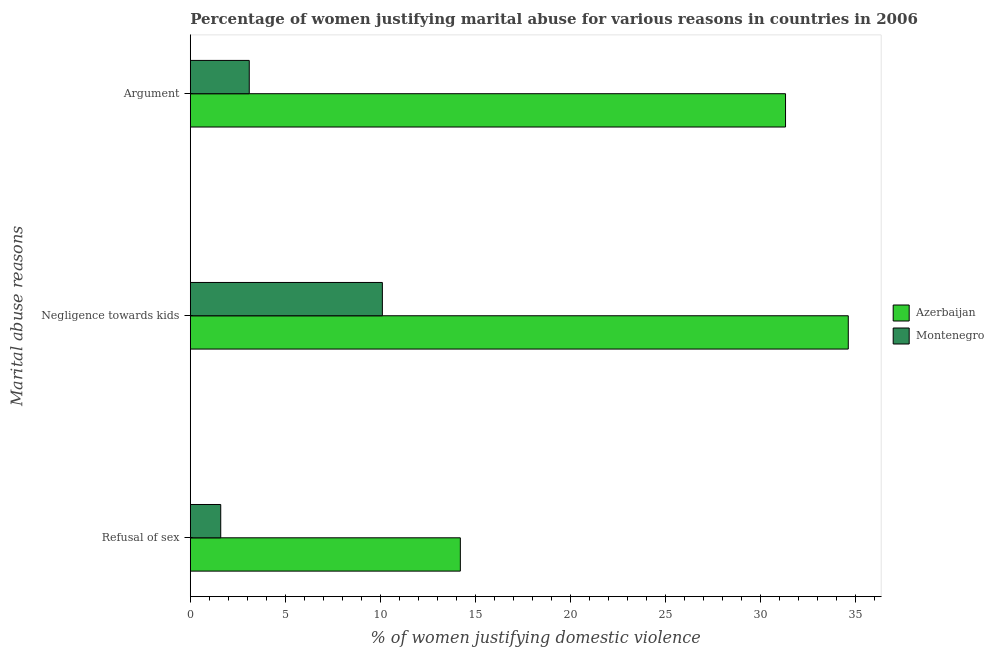Are the number of bars on each tick of the Y-axis equal?
Your answer should be very brief. Yes. How many bars are there on the 1st tick from the top?
Keep it short and to the point. 2. What is the label of the 3rd group of bars from the top?
Make the answer very short. Refusal of sex. What is the percentage of women justifying domestic violence due to arguments in Azerbaijan?
Ensure brevity in your answer.  31.3. Across all countries, what is the maximum percentage of women justifying domestic violence due to negligence towards kids?
Your response must be concise. 34.6. In which country was the percentage of women justifying domestic violence due to arguments maximum?
Make the answer very short. Azerbaijan. In which country was the percentage of women justifying domestic violence due to arguments minimum?
Provide a succinct answer. Montenegro. What is the total percentage of women justifying domestic violence due to refusal of sex in the graph?
Offer a very short reply. 15.8. What is the difference between the percentage of women justifying domestic violence due to negligence towards kids in Azerbaijan and the percentage of women justifying domestic violence due to refusal of sex in Montenegro?
Your response must be concise. 33. What is the average percentage of women justifying domestic violence due to negligence towards kids per country?
Keep it short and to the point. 22.35. What is the difference between the percentage of women justifying domestic violence due to arguments and percentage of women justifying domestic violence due to negligence towards kids in Azerbaijan?
Your answer should be compact. -3.3. What is the ratio of the percentage of women justifying domestic violence due to negligence towards kids in Azerbaijan to that in Montenegro?
Your answer should be very brief. 3.43. Is the percentage of women justifying domestic violence due to arguments in Montenegro less than that in Azerbaijan?
Ensure brevity in your answer.  Yes. Is the difference between the percentage of women justifying domestic violence due to refusal of sex in Azerbaijan and Montenegro greater than the difference between the percentage of women justifying domestic violence due to arguments in Azerbaijan and Montenegro?
Make the answer very short. No. What is the difference between the highest and the lowest percentage of women justifying domestic violence due to refusal of sex?
Your answer should be compact. 12.6. What does the 2nd bar from the top in Negligence towards kids represents?
Provide a short and direct response. Azerbaijan. What does the 1st bar from the bottom in Refusal of sex represents?
Your answer should be compact. Azerbaijan. How many bars are there?
Make the answer very short. 6. Are all the bars in the graph horizontal?
Make the answer very short. Yes. What is the difference between two consecutive major ticks on the X-axis?
Your answer should be compact. 5. Are the values on the major ticks of X-axis written in scientific E-notation?
Offer a very short reply. No. Does the graph contain any zero values?
Your answer should be compact. No. Does the graph contain grids?
Make the answer very short. No. Where does the legend appear in the graph?
Offer a very short reply. Center right. How many legend labels are there?
Your answer should be very brief. 2. How are the legend labels stacked?
Your response must be concise. Vertical. What is the title of the graph?
Offer a terse response. Percentage of women justifying marital abuse for various reasons in countries in 2006. Does "Peru" appear as one of the legend labels in the graph?
Offer a terse response. No. What is the label or title of the X-axis?
Give a very brief answer. % of women justifying domestic violence. What is the label or title of the Y-axis?
Your answer should be compact. Marital abuse reasons. What is the % of women justifying domestic violence of Azerbaijan in Refusal of sex?
Ensure brevity in your answer.  14.2. What is the % of women justifying domestic violence in Azerbaijan in Negligence towards kids?
Make the answer very short. 34.6. What is the % of women justifying domestic violence of Azerbaijan in Argument?
Ensure brevity in your answer.  31.3. Across all Marital abuse reasons, what is the maximum % of women justifying domestic violence of Azerbaijan?
Offer a very short reply. 34.6. Across all Marital abuse reasons, what is the minimum % of women justifying domestic violence in Azerbaijan?
Your response must be concise. 14.2. What is the total % of women justifying domestic violence of Azerbaijan in the graph?
Give a very brief answer. 80.1. What is the difference between the % of women justifying domestic violence in Azerbaijan in Refusal of sex and that in Negligence towards kids?
Keep it short and to the point. -20.4. What is the difference between the % of women justifying domestic violence of Montenegro in Refusal of sex and that in Negligence towards kids?
Provide a short and direct response. -8.5. What is the difference between the % of women justifying domestic violence in Azerbaijan in Refusal of sex and that in Argument?
Provide a succinct answer. -17.1. What is the difference between the % of women justifying domestic violence in Azerbaijan in Refusal of sex and the % of women justifying domestic violence in Montenegro in Negligence towards kids?
Make the answer very short. 4.1. What is the difference between the % of women justifying domestic violence of Azerbaijan in Negligence towards kids and the % of women justifying domestic violence of Montenegro in Argument?
Keep it short and to the point. 31.5. What is the average % of women justifying domestic violence in Azerbaijan per Marital abuse reasons?
Give a very brief answer. 26.7. What is the average % of women justifying domestic violence in Montenegro per Marital abuse reasons?
Your response must be concise. 4.93. What is the difference between the % of women justifying domestic violence of Azerbaijan and % of women justifying domestic violence of Montenegro in Refusal of sex?
Provide a succinct answer. 12.6. What is the difference between the % of women justifying domestic violence in Azerbaijan and % of women justifying domestic violence in Montenegro in Negligence towards kids?
Your answer should be very brief. 24.5. What is the difference between the % of women justifying domestic violence of Azerbaijan and % of women justifying domestic violence of Montenegro in Argument?
Offer a very short reply. 28.2. What is the ratio of the % of women justifying domestic violence in Azerbaijan in Refusal of sex to that in Negligence towards kids?
Offer a very short reply. 0.41. What is the ratio of the % of women justifying domestic violence of Montenegro in Refusal of sex to that in Negligence towards kids?
Ensure brevity in your answer.  0.16. What is the ratio of the % of women justifying domestic violence in Azerbaijan in Refusal of sex to that in Argument?
Keep it short and to the point. 0.45. What is the ratio of the % of women justifying domestic violence of Montenegro in Refusal of sex to that in Argument?
Your answer should be compact. 0.52. What is the ratio of the % of women justifying domestic violence in Azerbaijan in Negligence towards kids to that in Argument?
Provide a short and direct response. 1.11. What is the ratio of the % of women justifying domestic violence in Montenegro in Negligence towards kids to that in Argument?
Your answer should be very brief. 3.26. What is the difference between the highest and the second highest % of women justifying domestic violence of Azerbaijan?
Your response must be concise. 3.3. What is the difference between the highest and the second highest % of women justifying domestic violence of Montenegro?
Provide a short and direct response. 7. What is the difference between the highest and the lowest % of women justifying domestic violence of Azerbaijan?
Your response must be concise. 20.4. What is the difference between the highest and the lowest % of women justifying domestic violence of Montenegro?
Make the answer very short. 8.5. 